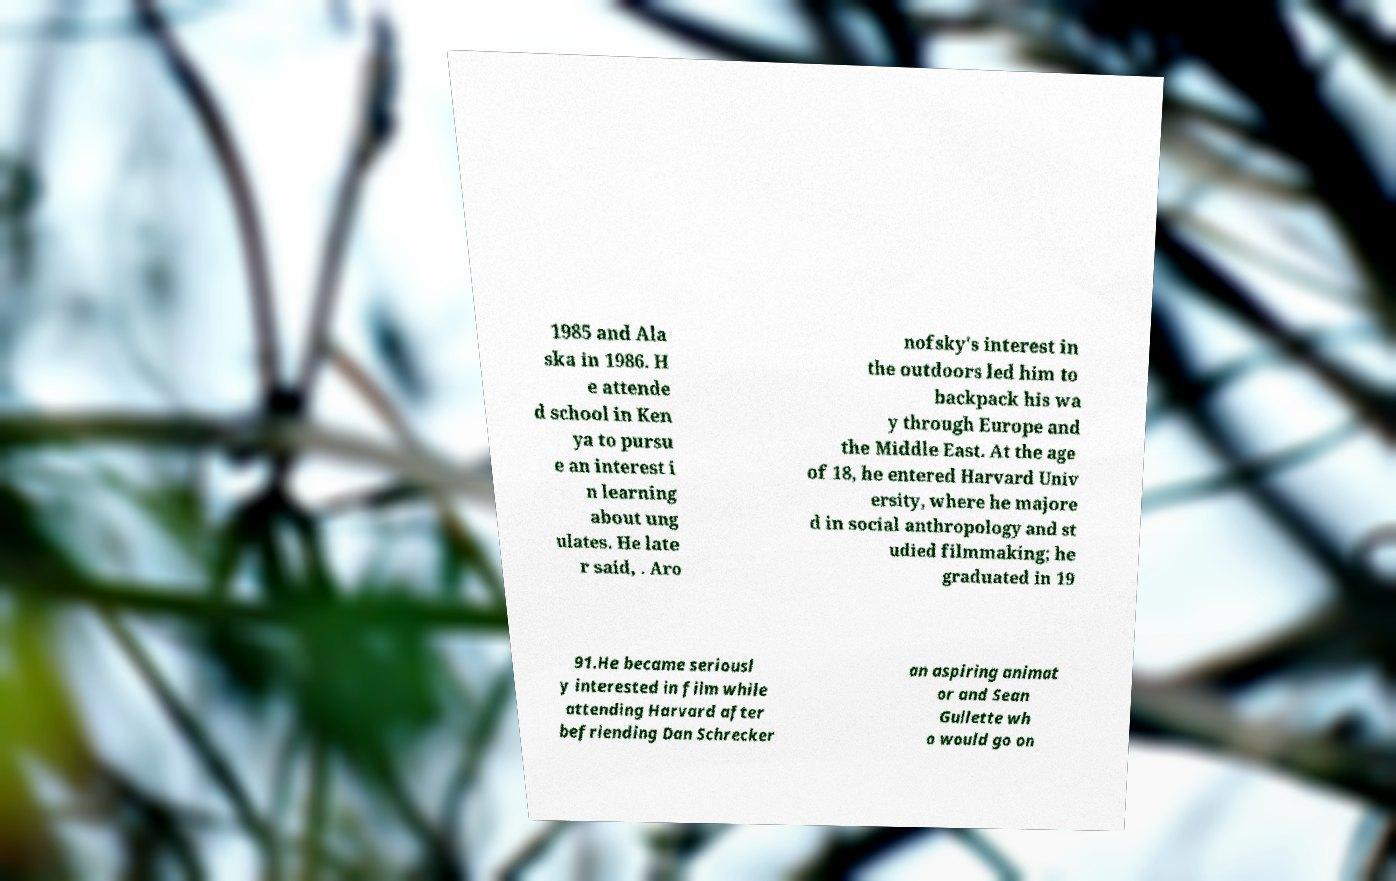For documentation purposes, I need the text within this image transcribed. Could you provide that? 1985 and Ala ska in 1986. H e attende d school in Ken ya to pursu e an interest i n learning about ung ulates. He late r said, . Aro nofsky's interest in the outdoors led him to backpack his wa y through Europe and the Middle East. At the age of 18, he entered Harvard Univ ersity, where he majore d in social anthropology and st udied filmmaking; he graduated in 19 91.He became seriousl y interested in film while attending Harvard after befriending Dan Schrecker an aspiring animat or and Sean Gullette wh o would go on 